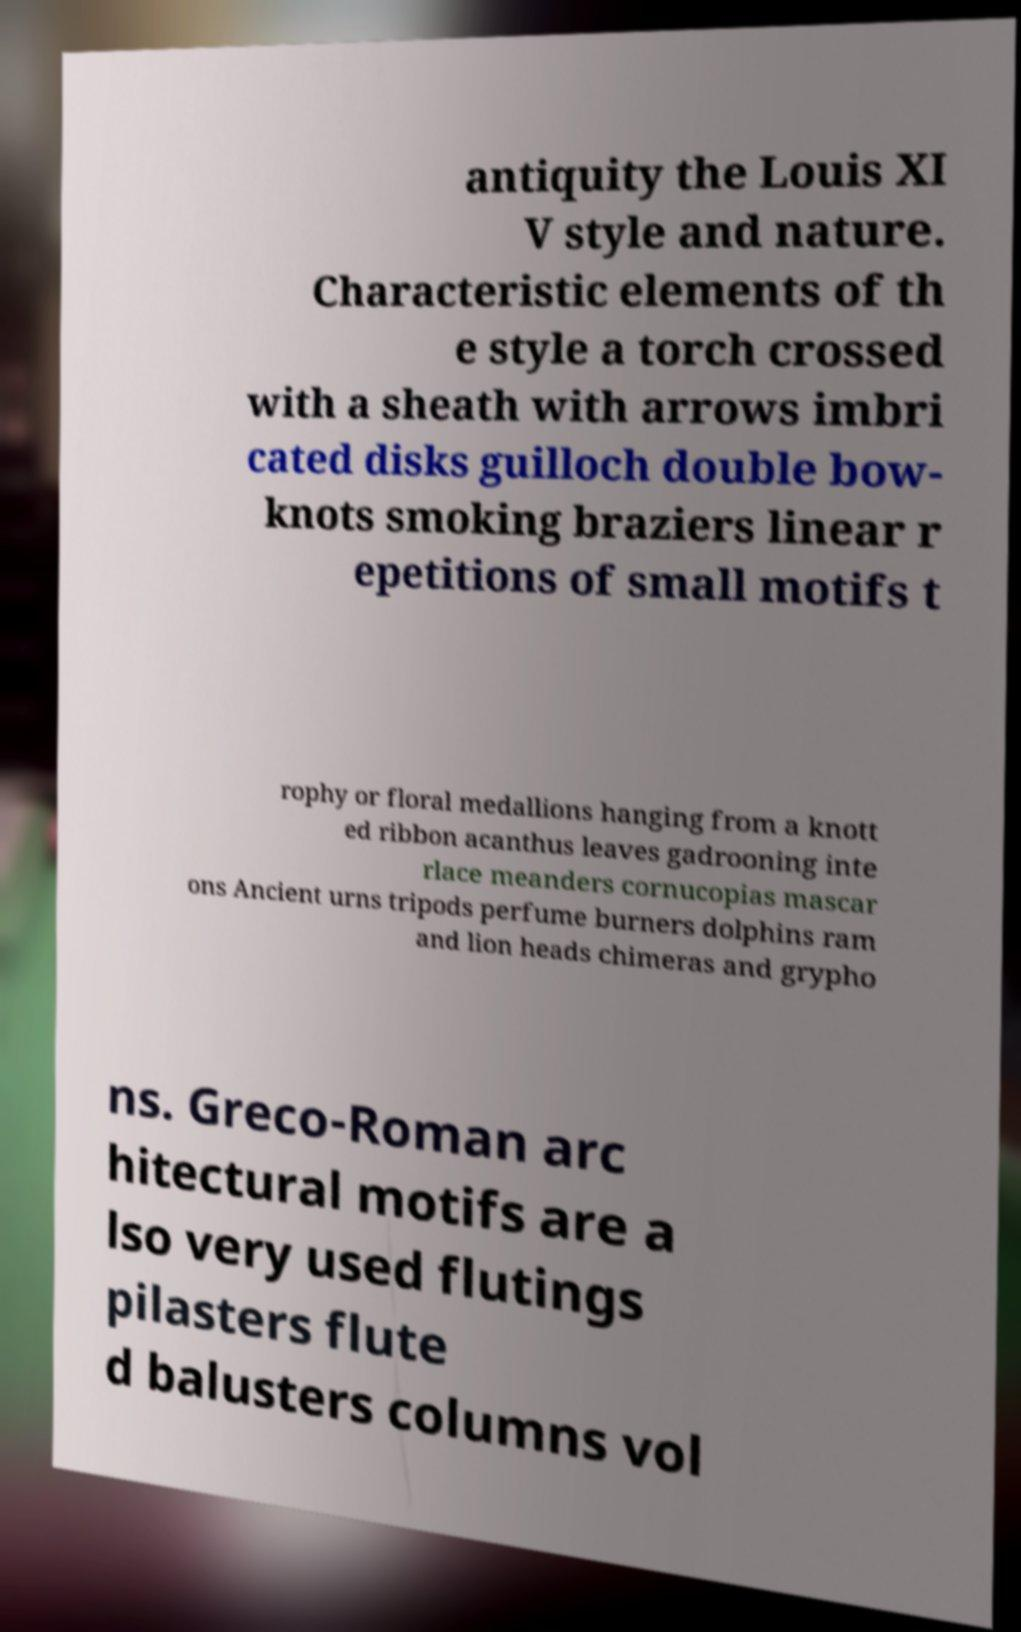Please identify and transcribe the text found in this image. antiquity the Louis XI V style and nature. Characteristic elements of th e style a torch crossed with a sheath with arrows imbri cated disks guilloch double bow- knots smoking braziers linear r epetitions of small motifs t rophy or floral medallions hanging from a knott ed ribbon acanthus leaves gadrooning inte rlace meanders cornucopias mascar ons Ancient urns tripods perfume burners dolphins ram and lion heads chimeras and grypho ns. Greco-Roman arc hitectural motifs are a lso very used flutings pilasters flute d balusters columns vol 